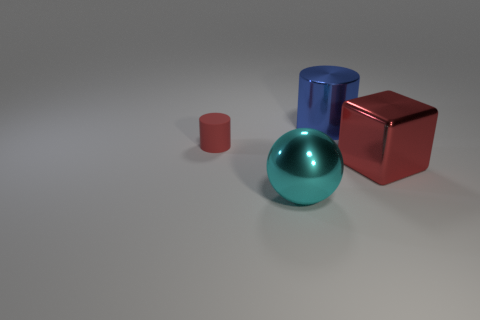Are there any other things that are the same shape as the big red metallic thing?
Provide a short and direct response. No. How many objects are either big yellow blocks or shiny things in front of the large metallic cylinder?
Offer a very short reply. 2. The large cylinder that is the same material as the cyan object is what color?
Offer a terse response. Blue. What number of things are large yellow balls or cylinders?
Give a very brief answer. 2. There is a ball that is the same size as the blue metal thing; what color is it?
Provide a short and direct response. Cyan. What number of objects are either metallic things behind the small red object or small blue cylinders?
Ensure brevity in your answer.  1. How many other objects are there of the same size as the cyan metallic thing?
Make the answer very short. 2. There is a red thing that is left of the large metallic block; what is its size?
Your response must be concise. Small. The big cyan object that is the same material as the large red object is what shape?
Ensure brevity in your answer.  Sphere. Is there anything else that is the same color as the large shiny block?
Provide a succinct answer. Yes. 